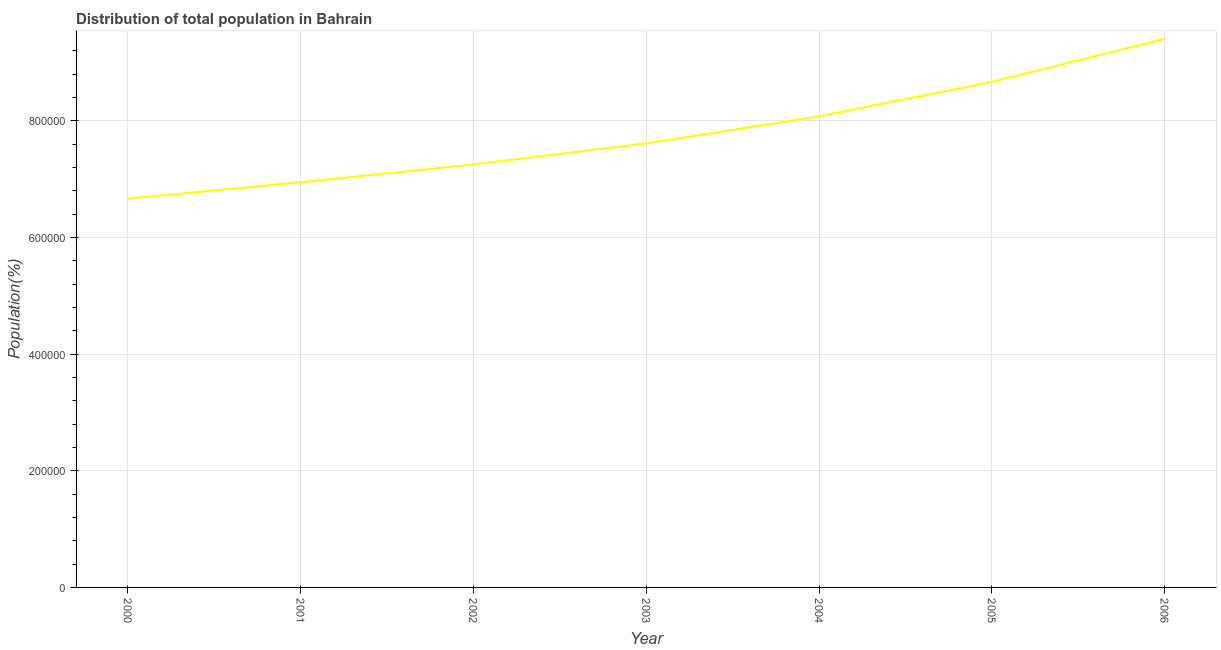What is the population in 2004?
Give a very brief answer. 8.08e+05. Across all years, what is the maximum population?
Ensure brevity in your answer.  9.41e+05. Across all years, what is the minimum population?
Your response must be concise. 6.67e+05. In which year was the population maximum?
Ensure brevity in your answer.  2006. In which year was the population minimum?
Offer a very short reply. 2000. What is the sum of the population?
Your answer should be compact. 5.46e+06. What is the difference between the population in 2000 and 2004?
Provide a succinct answer. -1.41e+05. What is the average population per year?
Provide a short and direct response. 7.81e+05. What is the median population?
Provide a succinct answer. 7.62e+05. In how many years, is the population greater than 480000 %?
Make the answer very short. 7. What is the ratio of the population in 2002 to that in 2005?
Your answer should be very brief. 0.84. Is the difference between the population in 2000 and 2001 greater than the difference between any two years?
Keep it short and to the point. No. What is the difference between the highest and the second highest population?
Provide a short and direct response. 7.38e+04. Is the sum of the population in 2000 and 2005 greater than the maximum population across all years?
Provide a succinct answer. Yes. What is the difference between the highest and the lowest population?
Keep it short and to the point. 2.74e+05. Does the graph contain any zero values?
Your answer should be very brief. No. Does the graph contain grids?
Ensure brevity in your answer.  Yes. What is the title of the graph?
Provide a succinct answer. Distribution of total population in Bahrain . What is the label or title of the X-axis?
Your answer should be compact. Year. What is the label or title of the Y-axis?
Offer a terse response. Population(%). What is the Population(%) of 2000?
Offer a terse response. 6.67e+05. What is the Population(%) of 2001?
Your answer should be very brief. 6.95e+05. What is the Population(%) of 2002?
Your response must be concise. 7.25e+05. What is the Population(%) of 2003?
Offer a terse response. 7.62e+05. What is the Population(%) in 2004?
Offer a terse response. 8.08e+05. What is the Population(%) in 2005?
Make the answer very short. 8.67e+05. What is the Population(%) in 2006?
Your answer should be compact. 9.41e+05. What is the difference between the Population(%) in 2000 and 2001?
Provide a succinct answer. -2.80e+04. What is the difference between the Population(%) in 2000 and 2002?
Provide a succinct answer. -5.85e+04. What is the difference between the Population(%) in 2000 and 2003?
Keep it short and to the point. -9.47e+04. What is the difference between the Population(%) in 2000 and 2004?
Your answer should be very brief. -1.41e+05. What is the difference between the Population(%) in 2000 and 2005?
Your response must be concise. -2.00e+05. What is the difference between the Population(%) in 2000 and 2006?
Your answer should be compact. -2.74e+05. What is the difference between the Population(%) in 2001 and 2002?
Make the answer very short. -3.05e+04. What is the difference between the Population(%) in 2001 and 2003?
Your answer should be very brief. -6.67e+04. What is the difference between the Population(%) in 2001 and 2004?
Ensure brevity in your answer.  -1.13e+05. What is the difference between the Population(%) in 2001 and 2005?
Provide a succinct answer. -1.72e+05. What is the difference between the Population(%) in 2001 and 2006?
Your answer should be compact. -2.46e+05. What is the difference between the Population(%) in 2002 and 2003?
Offer a terse response. -3.62e+04. What is the difference between the Population(%) in 2002 and 2004?
Your response must be concise. -8.26e+04. What is the difference between the Population(%) in 2002 and 2005?
Make the answer very short. -1.42e+05. What is the difference between the Population(%) in 2002 and 2006?
Provide a succinct answer. -2.15e+05. What is the difference between the Population(%) in 2003 and 2004?
Your response must be concise. -4.64e+04. What is the difference between the Population(%) in 2003 and 2005?
Make the answer very short. -1.05e+05. What is the difference between the Population(%) in 2003 and 2006?
Your answer should be compact. -1.79e+05. What is the difference between the Population(%) in 2004 and 2005?
Offer a very short reply. -5.90e+04. What is the difference between the Population(%) in 2004 and 2006?
Your answer should be compact. -1.33e+05. What is the difference between the Population(%) in 2005 and 2006?
Make the answer very short. -7.38e+04. What is the ratio of the Population(%) in 2000 to that in 2002?
Give a very brief answer. 0.92. What is the ratio of the Population(%) in 2000 to that in 2003?
Give a very brief answer. 0.88. What is the ratio of the Population(%) in 2000 to that in 2004?
Provide a succinct answer. 0.82. What is the ratio of the Population(%) in 2000 to that in 2005?
Give a very brief answer. 0.77. What is the ratio of the Population(%) in 2000 to that in 2006?
Make the answer very short. 0.71. What is the ratio of the Population(%) in 2001 to that in 2002?
Offer a very short reply. 0.96. What is the ratio of the Population(%) in 2001 to that in 2003?
Keep it short and to the point. 0.91. What is the ratio of the Population(%) in 2001 to that in 2004?
Offer a terse response. 0.86. What is the ratio of the Population(%) in 2001 to that in 2005?
Offer a terse response. 0.8. What is the ratio of the Population(%) in 2001 to that in 2006?
Provide a succinct answer. 0.74. What is the ratio of the Population(%) in 2002 to that in 2003?
Your answer should be very brief. 0.95. What is the ratio of the Population(%) in 2002 to that in 2004?
Provide a succinct answer. 0.9. What is the ratio of the Population(%) in 2002 to that in 2005?
Your response must be concise. 0.84. What is the ratio of the Population(%) in 2002 to that in 2006?
Your response must be concise. 0.77. What is the ratio of the Population(%) in 2003 to that in 2004?
Your answer should be compact. 0.94. What is the ratio of the Population(%) in 2003 to that in 2005?
Your answer should be very brief. 0.88. What is the ratio of the Population(%) in 2003 to that in 2006?
Give a very brief answer. 0.81. What is the ratio of the Population(%) in 2004 to that in 2005?
Provide a short and direct response. 0.93. What is the ratio of the Population(%) in 2004 to that in 2006?
Make the answer very short. 0.86. What is the ratio of the Population(%) in 2005 to that in 2006?
Offer a terse response. 0.92. 